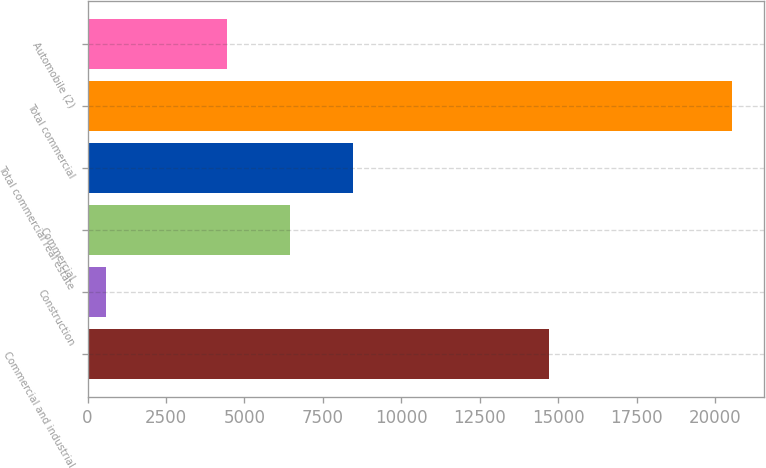Convert chart to OTSL. <chart><loc_0><loc_0><loc_500><loc_500><bar_chart><fcel>Commercial and industrial<fcel>Construction<fcel>Commercial<fcel>Total commercial real estate<fcel>Total commercial<fcel>Automobile (2)<nl><fcel>14699<fcel>580<fcel>6452.5<fcel>8447<fcel>20525<fcel>4458<nl></chart> 